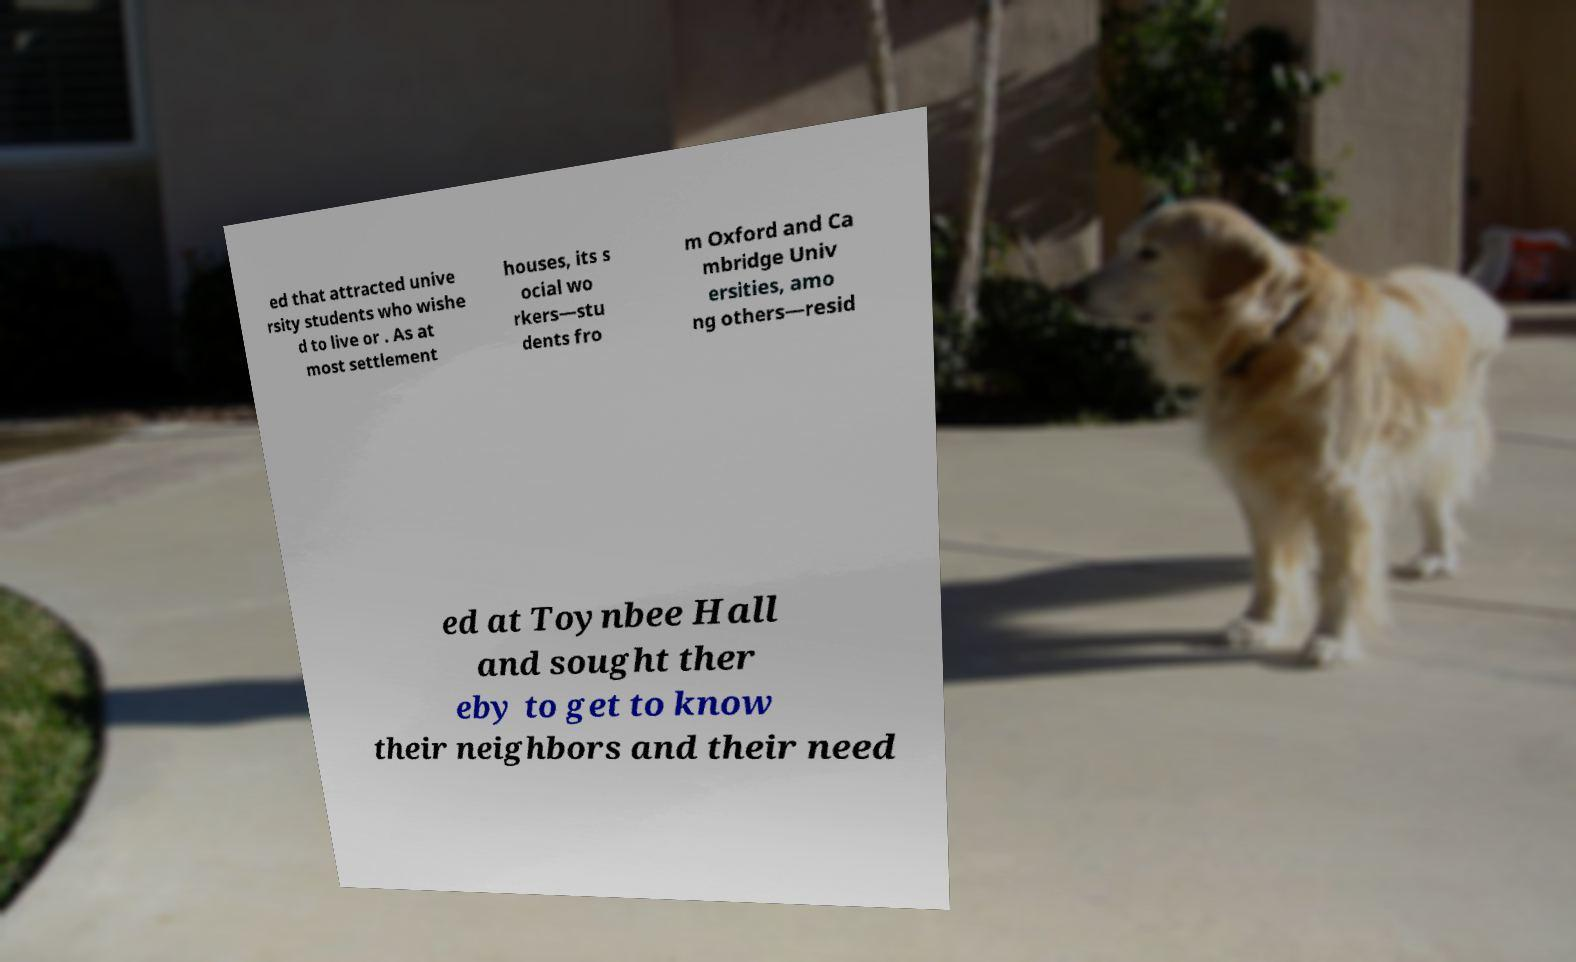Could you assist in decoding the text presented in this image and type it out clearly? ed that attracted unive rsity students who wishe d to live or . As at most settlement houses, its s ocial wo rkers—stu dents fro m Oxford and Ca mbridge Univ ersities, amo ng others—resid ed at Toynbee Hall and sought ther eby to get to know their neighbors and their need 